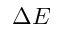<formula> <loc_0><loc_0><loc_500><loc_500>\Delta E</formula> 